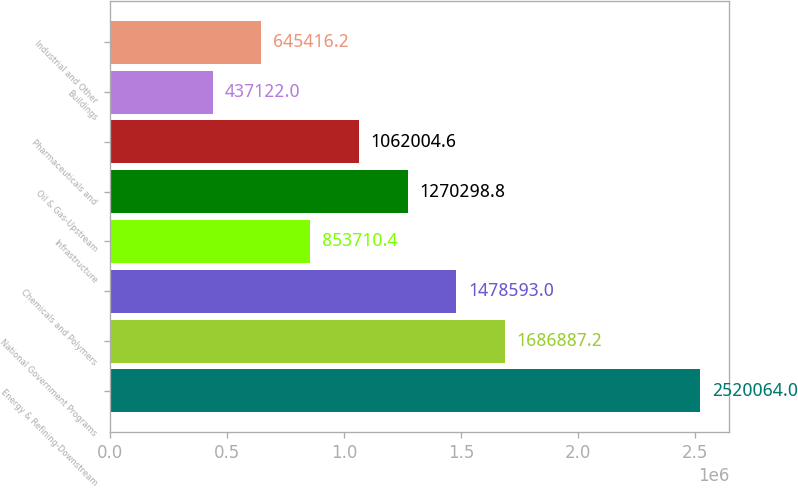Convert chart. <chart><loc_0><loc_0><loc_500><loc_500><bar_chart><fcel>Energy & Refining-Downstream<fcel>National Government Programs<fcel>Chemicals and Polymers<fcel>Infrastructure<fcel>Oil & Gas-Upstream<fcel>Pharmaceuticals and<fcel>Buildings<fcel>Industrial and Other<nl><fcel>2.52006e+06<fcel>1.68689e+06<fcel>1.47859e+06<fcel>853710<fcel>1.2703e+06<fcel>1.062e+06<fcel>437122<fcel>645416<nl></chart> 